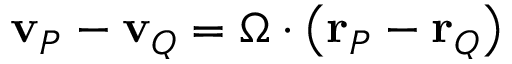Convert formula to latex. <formula><loc_0><loc_0><loc_500><loc_500>v _ { P } - v _ { Q } = { \Omega } \cdot \left ( r _ { P } - r _ { Q } \right )</formula> 